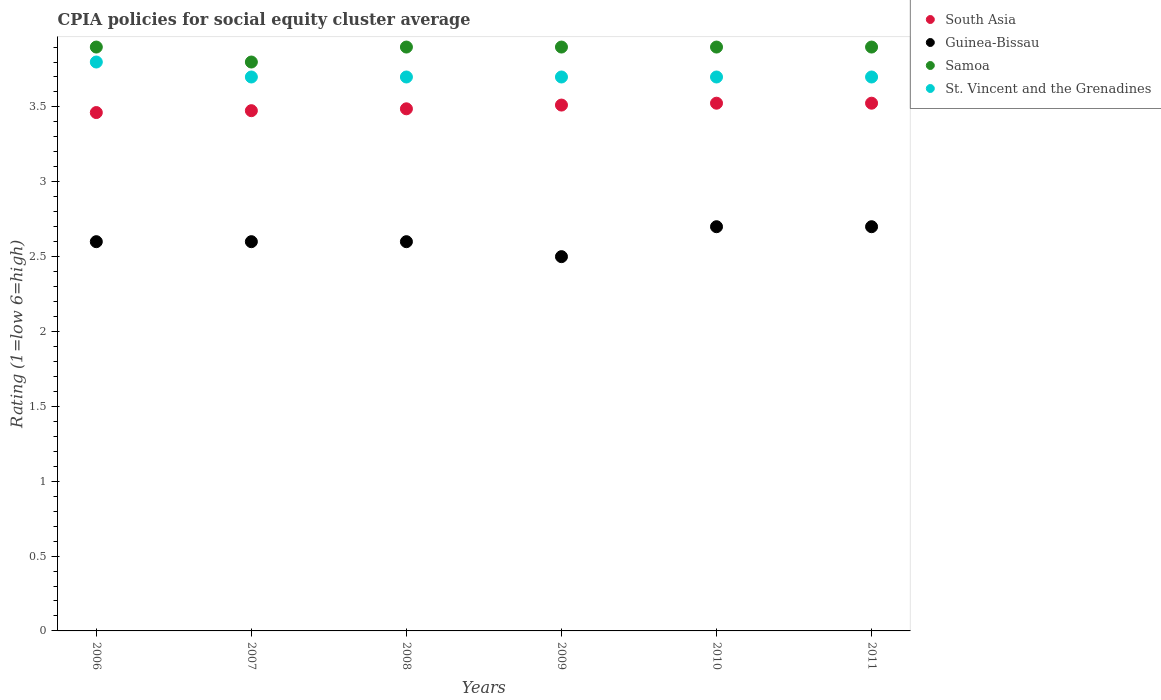Is the number of dotlines equal to the number of legend labels?
Give a very brief answer. Yes. What is the CPIA rating in South Asia in 2008?
Keep it short and to the point. 3.49. Across all years, what is the minimum CPIA rating in South Asia?
Your response must be concise. 3.46. In which year was the CPIA rating in St. Vincent and the Grenadines maximum?
Provide a succinct answer. 2006. What is the total CPIA rating in St. Vincent and the Grenadines in the graph?
Your answer should be very brief. 22.3. What is the difference between the CPIA rating in Guinea-Bissau in 2007 and that in 2011?
Offer a terse response. -0.1. What is the difference between the CPIA rating in St. Vincent and the Grenadines in 2007 and the CPIA rating in Guinea-Bissau in 2010?
Offer a terse response. 1. What is the average CPIA rating in Guinea-Bissau per year?
Give a very brief answer. 2.62. In the year 2007, what is the difference between the CPIA rating in Samoa and CPIA rating in Guinea-Bissau?
Make the answer very short. 1.2. What is the ratio of the CPIA rating in Guinea-Bissau in 2007 to that in 2010?
Give a very brief answer. 0.96. Is the CPIA rating in Samoa in 2009 less than that in 2011?
Your answer should be compact. No. What is the difference between the highest and the second highest CPIA rating in Samoa?
Provide a succinct answer. 0. What is the difference between the highest and the lowest CPIA rating in South Asia?
Offer a terse response. 0.06. Is it the case that in every year, the sum of the CPIA rating in Samoa and CPIA rating in St. Vincent and the Grenadines  is greater than the CPIA rating in Guinea-Bissau?
Your answer should be compact. Yes. Does the CPIA rating in St. Vincent and the Grenadines monotonically increase over the years?
Your response must be concise. No. How many dotlines are there?
Ensure brevity in your answer.  4. How many years are there in the graph?
Give a very brief answer. 6. Are the values on the major ticks of Y-axis written in scientific E-notation?
Your answer should be very brief. No. Does the graph contain grids?
Your answer should be very brief. No. Where does the legend appear in the graph?
Make the answer very short. Top right. How many legend labels are there?
Ensure brevity in your answer.  4. How are the legend labels stacked?
Your answer should be compact. Vertical. What is the title of the graph?
Provide a succinct answer. CPIA policies for social equity cluster average. Does "Tunisia" appear as one of the legend labels in the graph?
Your answer should be very brief. No. What is the Rating (1=low 6=high) in South Asia in 2006?
Offer a very short reply. 3.46. What is the Rating (1=low 6=high) in Guinea-Bissau in 2006?
Your response must be concise. 2.6. What is the Rating (1=low 6=high) in South Asia in 2007?
Offer a very short reply. 3.48. What is the Rating (1=low 6=high) in Samoa in 2007?
Ensure brevity in your answer.  3.8. What is the Rating (1=low 6=high) of South Asia in 2008?
Your answer should be compact. 3.49. What is the Rating (1=low 6=high) of Guinea-Bissau in 2008?
Keep it short and to the point. 2.6. What is the Rating (1=low 6=high) of South Asia in 2009?
Provide a short and direct response. 3.51. What is the Rating (1=low 6=high) of South Asia in 2010?
Offer a very short reply. 3.52. What is the Rating (1=low 6=high) in Samoa in 2010?
Offer a terse response. 3.9. What is the Rating (1=low 6=high) in St. Vincent and the Grenadines in 2010?
Your response must be concise. 3.7. What is the Rating (1=low 6=high) of South Asia in 2011?
Provide a succinct answer. 3.52. What is the Rating (1=low 6=high) of Samoa in 2011?
Offer a very short reply. 3.9. What is the Rating (1=low 6=high) of St. Vincent and the Grenadines in 2011?
Your answer should be very brief. 3.7. Across all years, what is the maximum Rating (1=low 6=high) of South Asia?
Keep it short and to the point. 3.52. Across all years, what is the maximum Rating (1=low 6=high) in Guinea-Bissau?
Give a very brief answer. 2.7. Across all years, what is the minimum Rating (1=low 6=high) in South Asia?
Make the answer very short. 3.46. Across all years, what is the minimum Rating (1=low 6=high) in Guinea-Bissau?
Offer a very short reply. 2.5. Across all years, what is the minimum Rating (1=low 6=high) in Samoa?
Your answer should be very brief. 3.8. What is the total Rating (1=low 6=high) of South Asia in the graph?
Offer a terse response. 20.99. What is the total Rating (1=low 6=high) in Samoa in the graph?
Provide a succinct answer. 23.3. What is the total Rating (1=low 6=high) in St. Vincent and the Grenadines in the graph?
Ensure brevity in your answer.  22.3. What is the difference between the Rating (1=low 6=high) of South Asia in 2006 and that in 2007?
Offer a terse response. -0.01. What is the difference between the Rating (1=low 6=high) in South Asia in 2006 and that in 2008?
Your answer should be compact. -0.03. What is the difference between the Rating (1=low 6=high) in Samoa in 2006 and that in 2008?
Ensure brevity in your answer.  0. What is the difference between the Rating (1=low 6=high) of South Asia in 2006 and that in 2009?
Keep it short and to the point. -0.05. What is the difference between the Rating (1=low 6=high) of South Asia in 2006 and that in 2010?
Keep it short and to the point. -0.06. What is the difference between the Rating (1=low 6=high) of South Asia in 2006 and that in 2011?
Offer a very short reply. -0.06. What is the difference between the Rating (1=low 6=high) in St. Vincent and the Grenadines in 2006 and that in 2011?
Offer a terse response. 0.1. What is the difference between the Rating (1=low 6=high) in South Asia in 2007 and that in 2008?
Your answer should be very brief. -0.01. What is the difference between the Rating (1=low 6=high) of Samoa in 2007 and that in 2008?
Offer a very short reply. -0.1. What is the difference between the Rating (1=low 6=high) in South Asia in 2007 and that in 2009?
Your response must be concise. -0.04. What is the difference between the Rating (1=low 6=high) of Guinea-Bissau in 2007 and that in 2009?
Offer a very short reply. 0.1. What is the difference between the Rating (1=low 6=high) of Samoa in 2007 and that in 2010?
Provide a succinct answer. -0.1. What is the difference between the Rating (1=low 6=high) in St. Vincent and the Grenadines in 2007 and that in 2010?
Your answer should be very brief. 0. What is the difference between the Rating (1=low 6=high) in South Asia in 2007 and that in 2011?
Offer a very short reply. -0.05. What is the difference between the Rating (1=low 6=high) of Guinea-Bissau in 2007 and that in 2011?
Your answer should be very brief. -0.1. What is the difference between the Rating (1=low 6=high) in South Asia in 2008 and that in 2009?
Offer a terse response. -0.03. What is the difference between the Rating (1=low 6=high) of Samoa in 2008 and that in 2009?
Provide a succinct answer. 0. What is the difference between the Rating (1=low 6=high) of St. Vincent and the Grenadines in 2008 and that in 2009?
Give a very brief answer. 0. What is the difference between the Rating (1=low 6=high) in South Asia in 2008 and that in 2010?
Offer a very short reply. -0.04. What is the difference between the Rating (1=low 6=high) of St. Vincent and the Grenadines in 2008 and that in 2010?
Your answer should be compact. 0. What is the difference between the Rating (1=low 6=high) of South Asia in 2008 and that in 2011?
Offer a terse response. -0.04. What is the difference between the Rating (1=low 6=high) of Guinea-Bissau in 2008 and that in 2011?
Offer a very short reply. -0.1. What is the difference between the Rating (1=low 6=high) in Samoa in 2008 and that in 2011?
Keep it short and to the point. 0. What is the difference between the Rating (1=low 6=high) in St. Vincent and the Grenadines in 2008 and that in 2011?
Give a very brief answer. 0. What is the difference between the Rating (1=low 6=high) in South Asia in 2009 and that in 2010?
Provide a short and direct response. -0.01. What is the difference between the Rating (1=low 6=high) of Guinea-Bissau in 2009 and that in 2010?
Your answer should be very brief. -0.2. What is the difference between the Rating (1=low 6=high) in South Asia in 2009 and that in 2011?
Provide a short and direct response. -0.01. What is the difference between the Rating (1=low 6=high) of Samoa in 2009 and that in 2011?
Your answer should be very brief. 0. What is the difference between the Rating (1=low 6=high) in St. Vincent and the Grenadines in 2009 and that in 2011?
Give a very brief answer. 0. What is the difference between the Rating (1=low 6=high) of South Asia in 2010 and that in 2011?
Keep it short and to the point. 0. What is the difference between the Rating (1=low 6=high) in South Asia in 2006 and the Rating (1=low 6=high) in Guinea-Bissau in 2007?
Make the answer very short. 0.86. What is the difference between the Rating (1=low 6=high) of South Asia in 2006 and the Rating (1=low 6=high) of Samoa in 2007?
Keep it short and to the point. -0.34. What is the difference between the Rating (1=low 6=high) in South Asia in 2006 and the Rating (1=low 6=high) in St. Vincent and the Grenadines in 2007?
Provide a short and direct response. -0.24. What is the difference between the Rating (1=low 6=high) in Guinea-Bissau in 2006 and the Rating (1=low 6=high) in St. Vincent and the Grenadines in 2007?
Provide a short and direct response. -1.1. What is the difference between the Rating (1=low 6=high) of Samoa in 2006 and the Rating (1=low 6=high) of St. Vincent and the Grenadines in 2007?
Ensure brevity in your answer.  0.2. What is the difference between the Rating (1=low 6=high) of South Asia in 2006 and the Rating (1=low 6=high) of Guinea-Bissau in 2008?
Make the answer very short. 0.86. What is the difference between the Rating (1=low 6=high) of South Asia in 2006 and the Rating (1=low 6=high) of Samoa in 2008?
Provide a short and direct response. -0.44. What is the difference between the Rating (1=low 6=high) in South Asia in 2006 and the Rating (1=low 6=high) in St. Vincent and the Grenadines in 2008?
Offer a very short reply. -0.24. What is the difference between the Rating (1=low 6=high) of South Asia in 2006 and the Rating (1=low 6=high) of Guinea-Bissau in 2009?
Offer a very short reply. 0.96. What is the difference between the Rating (1=low 6=high) of South Asia in 2006 and the Rating (1=low 6=high) of Samoa in 2009?
Offer a terse response. -0.44. What is the difference between the Rating (1=low 6=high) of South Asia in 2006 and the Rating (1=low 6=high) of St. Vincent and the Grenadines in 2009?
Provide a succinct answer. -0.24. What is the difference between the Rating (1=low 6=high) in Guinea-Bissau in 2006 and the Rating (1=low 6=high) in Samoa in 2009?
Make the answer very short. -1.3. What is the difference between the Rating (1=low 6=high) in Samoa in 2006 and the Rating (1=low 6=high) in St. Vincent and the Grenadines in 2009?
Your answer should be compact. 0.2. What is the difference between the Rating (1=low 6=high) in South Asia in 2006 and the Rating (1=low 6=high) in Guinea-Bissau in 2010?
Provide a succinct answer. 0.76. What is the difference between the Rating (1=low 6=high) of South Asia in 2006 and the Rating (1=low 6=high) of Samoa in 2010?
Provide a short and direct response. -0.44. What is the difference between the Rating (1=low 6=high) in South Asia in 2006 and the Rating (1=low 6=high) in St. Vincent and the Grenadines in 2010?
Give a very brief answer. -0.24. What is the difference between the Rating (1=low 6=high) in South Asia in 2006 and the Rating (1=low 6=high) in Guinea-Bissau in 2011?
Offer a terse response. 0.76. What is the difference between the Rating (1=low 6=high) of South Asia in 2006 and the Rating (1=low 6=high) of Samoa in 2011?
Provide a short and direct response. -0.44. What is the difference between the Rating (1=low 6=high) of South Asia in 2006 and the Rating (1=low 6=high) of St. Vincent and the Grenadines in 2011?
Ensure brevity in your answer.  -0.24. What is the difference between the Rating (1=low 6=high) of Samoa in 2006 and the Rating (1=low 6=high) of St. Vincent and the Grenadines in 2011?
Give a very brief answer. 0.2. What is the difference between the Rating (1=low 6=high) in South Asia in 2007 and the Rating (1=low 6=high) in Samoa in 2008?
Provide a succinct answer. -0.42. What is the difference between the Rating (1=low 6=high) in South Asia in 2007 and the Rating (1=low 6=high) in St. Vincent and the Grenadines in 2008?
Keep it short and to the point. -0.23. What is the difference between the Rating (1=low 6=high) of Guinea-Bissau in 2007 and the Rating (1=low 6=high) of Samoa in 2008?
Give a very brief answer. -1.3. What is the difference between the Rating (1=low 6=high) in Guinea-Bissau in 2007 and the Rating (1=low 6=high) in St. Vincent and the Grenadines in 2008?
Give a very brief answer. -1.1. What is the difference between the Rating (1=low 6=high) of South Asia in 2007 and the Rating (1=low 6=high) of Guinea-Bissau in 2009?
Ensure brevity in your answer.  0.97. What is the difference between the Rating (1=low 6=high) of South Asia in 2007 and the Rating (1=low 6=high) of Samoa in 2009?
Give a very brief answer. -0.42. What is the difference between the Rating (1=low 6=high) of South Asia in 2007 and the Rating (1=low 6=high) of St. Vincent and the Grenadines in 2009?
Provide a short and direct response. -0.23. What is the difference between the Rating (1=low 6=high) in Guinea-Bissau in 2007 and the Rating (1=low 6=high) in Samoa in 2009?
Your answer should be compact. -1.3. What is the difference between the Rating (1=low 6=high) of Guinea-Bissau in 2007 and the Rating (1=low 6=high) of St. Vincent and the Grenadines in 2009?
Provide a short and direct response. -1.1. What is the difference between the Rating (1=low 6=high) of South Asia in 2007 and the Rating (1=low 6=high) of Guinea-Bissau in 2010?
Give a very brief answer. 0.78. What is the difference between the Rating (1=low 6=high) of South Asia in 2007 and the Rating (1=low 6=high) of Samoa in 2010?
Your answer should be compact. -0.42. What is the difference between the Rating (1=low 6=high) in South Asia in 2007 and the Rating (1=low 6=high) in St. Vincent and the Grenadines in 2010?
Offer a terse response. -0.23. What is the difference between the Rating (1=low 6=high) of South Asia in 2007 and the Rating (1=low 6=high) of Guinea-Bissau in 2011?
Keep it short and to the point. 0.78. What is the difference between the Rating (1=low 6=high) of South Asia in 2007 and the Rating (1=low 6=high) of Samoa in 2011?
Offer a terse response. -0.42. What is the difference between the Rating (1=low 6=high) in South Asia in 2007 and the Rating (1=low 6=high) in St. Vincent and the Grenadines in 2011?
Your answer should be compact. -0.23. What is the difference between the Rating (1=low 6=high) of Guinea-Bissau in 2007 and the Rating (1=low 6=high) of Samoa in 2011?
Make the answer very short. -1.3. What is the difference between the Rating (1=low 6=high) of Guinea-Bissau in 2007 and the Rating (1=low 6=high) of St. Vincent and the Grenadines in 2011?
Offer a terse response. -1.1. What is the difference between the Rating (1=low 6=high) in South Asia in 2008 and the Rating (1=low 6=high) in Guinea-Bissau in 2009?
Your answer should be very brief. 0.99. What is the difference between the Rating (1=low 6=high) in South Asia in 2008 and the Rating (1=low 6=high) in Samoa in 2009?
Make the answer very short. -0.41. What is the difference between the Rating (1=low 6=high) of South Asia in 2008 and the Rating (1=low 6=high) of St. Vincent and the Grenadines in 2009?
Offer a terse response. -0.21. What is the difference between the Rating (1=low 6=high) of Guinea-Bissau in 2008 and the Rating (1=low 6=high) of St. Vincent and the Grenadines in 2009?
Offer a very short reply. -1.1. What is the difference between the Rating (1=low 6=high) of South Asia in 2008 and the Rating (1=low 6=high) of Guinea-Bissau in 2010?
Make the answer very short. 0.79. What is the difference between the Rating (1=low 6=high) in South Asia in 2008 and the Rating (1=low 6=high) in Samoa in 2010?
Your response must be concise. -0.41. What is the difference between the Rating (1=low 6=high) in South Asia in 2008 and the Rating (1=low 6=high) in St. Vincent and the Grenadines in 2010?
Your answer should be very brief. -0.21. What is the difference between the Rating (1=low 6=high) of Guinea-Bissau in 2008 and the Rating (1=low 6=high) of St. Vincent and the Grenadines in 2010?
Offer a terse response. -1.1. What is the difference between the Rating (1=low 6=high) in Samoa in 2008 and the Rating (1=low 6=high) in St. Vincent and the Grenadines in 2010?
Offer a very short reply. 0.2. What is the difference between the Rating (1=low 6=high) in South Asia in 2008 and the Rating (1=low 6=high) in Guinea-Bissau in 2011?
Give a very brief answer. 0.79. What is the difference between the Rating (1=low 6=high) of South Asia in 2008 and the Rating (1=low 6=high) of Samoa in 2011?
Make the answer very short. -0.41. What is the difference between the Rating (1=low 6=high) of South Asia in 2008 and the Rating (1=low 6=high) of St. Vincent and the Grenadines in 2011?
Give a very brief answer. -0.21. What is the difference between the Rating (1=low 6=high) in Guinea-Bissau in 2008 and the Rating (1=low 6=high) in St. Vincent and the Grenadines in 2011?
Give a very brief answer. -1.1. What is the difference between the Rating (1=low 6=high) in Samoa in 2008 and the Rating (1=low 6=high) in St. Vincent and the Grenadines in 2011?
Make the answer very short. 0.2. What is the difference between the Rating (1=low 6=high) in South Asia in 2009 and the Rating (1=low 6=high) in Guinea-Bissau in 2010?
Your answer should be compact. 0.81. What is the difference between the Rating (1=low 6=high) of South Asia in 2009 and the Rating (1=low 6=high) of Samoa in 2010?
Your answer should be very brief. -0.39. What is the difference between the Rating (1=low 6=high) of South Asia in 2009 and the Rating (1=low 6=high) of St. Vincent and the Grenadines in 2010?
Your answer should be compact. -0.19. What is the difference between the Rating (1=low 6=high) in Guinea-Bissau in 2009 and the Rating (1=low 6=high) in Samoa in 2010?
Keep it short and to the point. -1.4. What is the difference between the Rating (1=low 6=high) in Samoa in 2009 and the Rating (1=low 6=high) in St. Vincent and the Grenadines in 2010?
Keep it short and to the point. 0.2. What is the difference between the Rating (1=low 6=high) of South Asia in 2009 and the Rating (1=low 6=high) of Guinea-Bissau in 2011?
Make the answer very short. 0.81. What is the difference between the Rating (1=low 6=high) in South Asia in 2009 and the Rating (1=low 6=high) in Samoa in 2011?
Your answer should be compact. -0.39. What is the difference between the Rating (1=low 6=high) of South Asia in 2009 and the Rating (1=low 6=high) of St. Vincent and the Grenadines in 2011?
Give a very brief answer. -0.19. What is the difference between the Rating (1=low 6=high) in Guinea-Bissau in 2009 and the Rating (1=low 6=high) in Samoa in 2011?
Your response must be concise. -1.4. What is the difference between the Rating (1=low 6=high) in Guinea-Bissau in 2009 and the Rating (1=low 6=high) in St. Vincent and the Grenadines in 2011?
Offer a terse response. -1.2. What is the difference between the Rating (1=low 6=high) of Samoa in 2009 and the Rating (1=low 6=high) of St. Vincent and the Grenadines in 2011?
Your answer should be very brief. 0.2. What is the difference between the Rating (1=low 6=high) in South Asia in 2010 and the Rating (1=low 6=high) in Guinea-Bissau in 2011?
Make the answer very short. 0.82. What is the difference between the Rating (1=low 6=high) of South Asia in 2010 and the Rating (1=low 6=high) of Samoa in 2011?
Your response must be concise. -0.38. What is the difference between the Rating (1=low 6=high) of South Asia in 2010 and the Rating (1=low 6=high) of St. Vincent and the Grenadines in 2011?
Give a very brief answer. -0.17. What is the difference between the Rating (1=low 6=high) in Samoa in 2010 and the Rating (1=low 6=high) in St. Vincent and the Grenadines in 2011?
Your response must be concise. 0.2. What is the average Rating (1=low 6=high) of South Asia per year?
Make the answer very short. 3.5. What is the average Rating (1=low 6=high) of Guinea-Bissau per year?
Provide a succinct answer. 2.62. What is the average Rating (1=low 6=high) of Samoa per year?
Make the answer very short. 3.88. What is the average Rating (1=low 6=high) of St. Vincent and the Grenadines per year?
Give a very brief answer. 3.72. In the year 2006, what is the difference between the Rating (1=low 6=high) of South Asia and Rating (1=low 6=high) of Guinea-Bissau?
Your answer should be compact. 0.86. In the year 2006, what is the difference between the Rating (1=low 6=high) of South Asia and Rating (1=low 6=high) of Samoa?
Offer a terse response. -0.44. In the year 2006, what is the difference between the Rating (1=low 6=high) of South Asia and Rating (1=low 6=high) of St. Vincent and the Grenadines?
Keep it short and to the point. -0.34. In the year 2006, what is the difference between the Rating (1=low 6=high) of Samoa and Rating (1=low 6=high) of St. Vincent and the Grenadines?
Your answer should be compact. 0.1. In the year 2007, what is the difference between the Rating (1=low 6=high) of South Asia and Rating (1=low 6=high) of Guinea-Bissau?
Make the answer very short. 0.88. In the year 2007, what is the difference between the Rating (1=low 6=high) of South Asia and Rating (1=low 6=high) of Samoa?
Offer a terse response. -0.33. In the year 2007, what is the difference between the Rating (1=low 6=high) of South Asia and Rating (1=low 6=high) of St. Vincent and the Grenadines?
Make the answer very short. -0.23. In the year 2007, what is the difference between the Rating (1=low 6=high) of Guinea-Bissau and Rating (1=low 6=high) of St. Vincent and the Grenadines?
Your response must be concise. -1.1. In the year 2007, what is the difference between the Rating (1=low 6=high) of Samoa and Rating (1=low 6=high) of St. Vincent and the Grenadines?
Offer a very short reply. 0.1. In the year 2008, what is the difference between the Rating (1=low 6=high) of South Asia and Rating (1=low 6=high) of Guinea-Bissau?
Provide a short and direct response. 0.89. In the year 2008, what is the difference between the Rating (1=low 6=high) in South Asia and Rating (1=low 6=high) in Samoa?
Give a very brief answer. -0.41. In the year 2008, what is the difference between the Rating (1=low 6=high) in South Asia and Rating (1=low 6=high) in St. Vincent and the Grenadines?
Provide a short and direct response. -0.21. In the year 2008, what is the difference between the Rating (1=low 6=high) of Samoa and Rating (1=low 6=high) of St. Vincent and the Grenadines?
Your answer should be compact. 0.2. In the year 2009, what is the difference between the Rating (1=low 6=high) in South Asia and Rating (1=low 6=high) in Guinea-Bissau?
Give a very brief answer. 1.01. In the year 2009, what is the difference between the Rating (1=low 6=high) in South Asia and Rating (1=low 6=high) in Samoa?
Provide a short and direct response. -0.39. In the year 2009, what is the difference between the Rating (1=low 6=high) in South Asia and Rating (1=low 6=high) in St. Vincent and the Grenadines?
Your answer should be very brief. -0.19. In the year 2009, what is the difference between the Rating (1=low 6=high) of Guinea-Bissau and Rating (1=low 6=high) of St. Vincent and the Grenadines?
Give a very brief answer. -1.2. In the year 2009, what is the difference between the Rating (1=low 6=high) of Samoa and Rating (1=low 6=high) of St. Vincent and the Grenadines?
Provide a short and direct response. 0.2. In the year 2010, what is the difference between the Rating (1=low 6=high) of South Asia and Rating (1=low 6=high) of Guinea-Bissau?
Offer a very short reply. 0.82. In the year 2010, what is the difference between the Rating (1=low 6=high) in South Asia and Rating (1=low 6=high) in Samoa?
Offer a terse response. -0.38. In the year 2010, what is the difference between the Rating (1=low 6=high) in South Asia and Rating (1=low 6=high) in St. Vincent and the Grenadines?
Your response must be concise. -0.17. In the year 2010, what is the difference between the Rating (1=low 6=high) of Guinea-Bissau and Rating (1=low 6=high) of St. Vincent and the Grenadines?
Ensure brevity in your answer.  -1. In the year 2011, what is the difference between the Rating (1=low 6=high) of South Asia and Rating (1=low 6=high) of Guinea-Bissau?
Your answer should be compact. 0.82. In the year 2011, what is the difference between the Rating (1=low 6=high) of South Asia and Rating (1=low 6=high) of Samoa?
Give a very brief answer. -0.38. In the year 2011, what is the difference between the Rating (1=low 6=high) of South Asia and Rating (1=low 6=high) of St. Vincent and the Grenadines?
Your answer should be very brief. -0.17. What is the ratio of the Rating (1=low 6=high) of Samoa in 2006 to that in 2007?
Your answer should be compact. 1.03. What is the ratio of the Rating (1=low 6=high) in South Asia in 2006 to that in 2008?
Offer a terse response. 0.99. What is the ratio of the Rating (1=low 6=high) in Samoa in 2006 to that in 2008?
Provide a short and direct response. 1. What is the ratio of the Rating (1=low 6=high) in South Asia in 2006 to that in 2009?
Offer a very short reply. 0.99. What is the ratio of the Rating (1=low 6=high) of Samoa in 2006 to that in 2009?
Keep it short and to the point. 1. What is the ratio of the Rating (1=low 6=high) in St. Vincent and the Grenadines in 2006 to that in 2009?
Ensure brevity in your answer.  1.03. What is the ratio of the Rating (1=low 6=high) of South Asia in 2006 to that in 2010?
Your response must be concise. 0.98. What is the ratio of the Rating (1=low 6=high) of Guinea-Bissau in 2006 to that in 2010?
Your answer should be very brief. 0.96. What is the ratio of the Rating (1=low 6=high) of Samoa in 2006 to that in 2010?
Your answer should be very brief. 1. What is the ratio of the Rating (1=low 6=high) of South Asia in 2006 to that in 2011?
Ensure brevity in your answer.  0.98. What is the ratio of the Rating (1=low 6=high) of Guinea-Bissau in 2006 to that in 2011?
Offer a terse response. 0.96. What is the ratio of the Rating (1=low 6=high) of St. Vincent and the Grenadines in 2006 to that in 2011?
Your response must be concise. 1.03. What is the ratio of the Rating (1=low 6=high) in South Asia in 2007 to that in 2008?
Offer a very short reply. 1. What is the ratio of the Rating (1=low 6=high) of Samoa in 2007 to that in 2008?
Ensure brevity in your answer.  0.97. What is the ratio of the Rating (1=low 6=high) in South Asia in 2007 to that in 2009?
Give a very brief answer. 0.99. What is the ratio of the Rating (1=low 6=high) of Guinea-Bissau in 2007 to that in 2009?
Keep it short and to the point. 1.04. What is the ratio of the Rating (1=low 6=high) in Samoa in 2007 to that in 2009?
Your response must be concise. 0.97. What is the ratio of the Rating (1=low 6=high) of St. Vincent and the Grenadines in 2007 to that in 2009?
Offer a terse response. 1. What is the ratio of the Rating (1=low 6=high) of South Asia in 2007 to that in 2010?
Ensure brevity in your answer.  0.99. What is the ratio of the Rating (1=low 6=high) in Samoa in 2007 to that in 2010?
Ensure brevity in your answer.  0.97. What is the ratio of the Rating (1=low 6=high) of South Asia in 2007 to that in 2011?
Make the answer very short. 0.99. What is the ratio of the Rating (1=low 6=high) of Samoa in 2007 to that in 2011?
Offer a terse response. 0.97. What is the ratio of the Rating (1=low 6=high) in South Asia in 2008 to that in 2009?
Your answer should be very brief. 0.99. What is the ratio of the Rating (1=low 6=high) in Guinea-Bissau in 2008 to that in 2009?
Offer a terse response. 1.04. What is the ratio of the Rating (1=low 6=high) of Guinea-Bissau in 2008 to that in 2010?
Your response must be concise. 0.96. What is the ratio of the Rating (1=low 6=high) in St. Vincent and the Grenadines in 2008 to that in 2010?
Ensure brevity in your answer.  1. What is the ratio of the Rating (1=low 6=high) in Guinea-Bissau in 2008 to that in 2011?
Offer a terse response. 0.96. What is the ratio of the Rating (1=low 6=high) in St. Vincent and the Grenadines in 2008 to that in 2011?
Make the answer very short. 1. What is the ratio of the Rating (1=low 6=high) in South Asia in 2009 to that in 2010?
Offer a terse response. 1. What is the ratio of the Rating (1=low 6=high) in Guinea-Bissau in 2009 to that in 2010?
Offer a terse response. 0.93. What is the ratio of the Rating (1=low 6=high) in St. Vincent and the Grenadines in 2009 to that in 2010?
Your answer should be very brief. 1. What is the ratio of the Rating (1=low 6=high) of South Asia in 2009 to that in 2011?
Your answer should be compact. 1. What is the ratio of the Rating (1=low 6=high) of Guinea-Bissau in 2009 to that in 2011?
Provide a short and direct response. 0.93. What is the ratio of the Rating (1=low 6=high) of Samoa in 2009 to that in 2011?
Your response must be concise. 1. What is the ratio of the Rating (1=low 6=high) of St. Vincent and the Grenadines in 2009 to that in 2011?
Give a very brief answer. 1. What is the ratio of the Rating (1=low 6=high) of Samoa in 2010 to that in 2011?
Your answer should be very brief. 1. What is the ratio of the Rating (1=low 6=high) in St. Vincent and the Grenadines in 2010 to that in 2011?
Provide a short and direct response. 1. What is the difference between the highest and the second highest Rating (1=low 6=high) of South Asia?
Offer a terse response. 0. What is the difference between the highest and the second highest Rating (1=low 6=high) of Guinea-Bissau?
Provide a succinct answer. 0. What is the difference between the highest and the second highest Rating (1=low 6=high) in Samoa?
Ensure brevity in your answer.  0. What is the difference between the highest and the second highest Rating (1=low 6=high) of St. Vincent and the Grenadines?
Provide a short and direct response. 0.1. What is the difference between the highest and the lowest Rating (1=low 6=high) in South Asia?
Keep it short and to the point. 0.06. What is the difference between the highest and the lowest Rating (1=low 6=high) in Guinea-Bissau?
Your answer should be compact. 0.2. 